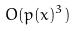Convert formula to latex. <formula><loc_0><loc_0><loc_500><loc_500>O ( p ( x ) ^ { 3 } )</formula> 